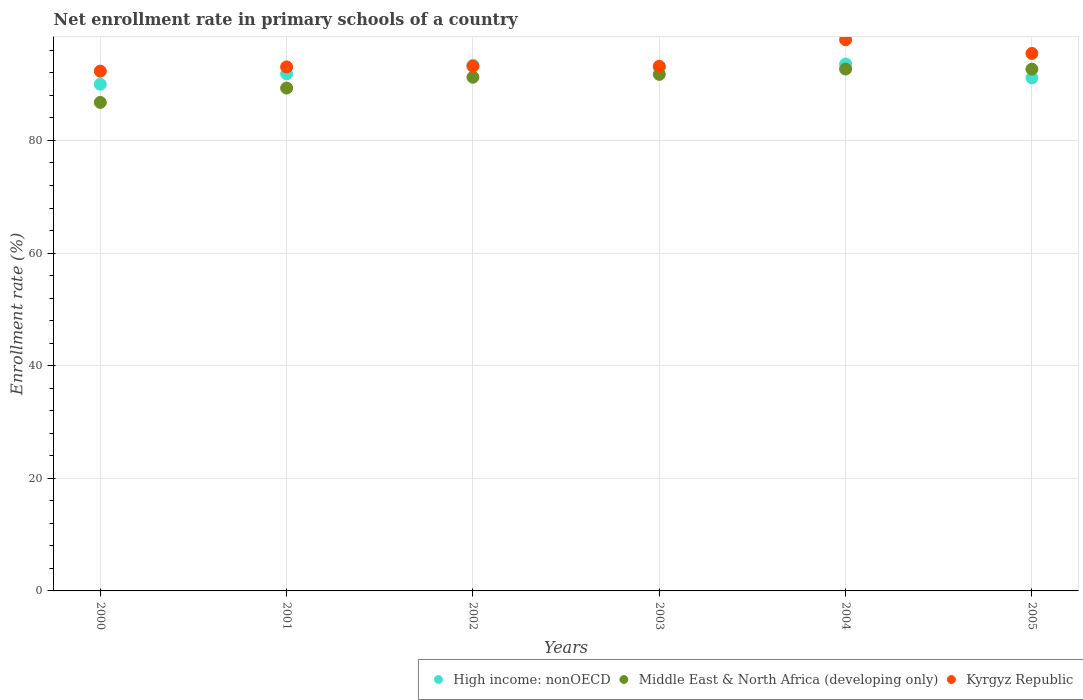How many different coloured dotlines are there?
Offer a terse response. 3. Is the number of dotlines equal to the number of legend labels?
Your response must be concise. Yes. What is the enrollment rate in primary schools in High income: nonOECD in 2004?
Make the answer very short. 93.57. Across all years, what is the maximum enrollment rate in primary schools in High income: nonOECD?
Give a very brief answer. 93.57. Across all years, what is the minimum enrollment rate in primary schools in High income: nonOECD?
Your response must be concise. 89.98. In which year was the enrollment rate in primary schools in High income: nonOECD maximum?
Ensure brevity in your answer.  2004. What is the total enrollment rate in primary schools in High income: nonOECD in the graph?
Offer a very short reply. 552.82. What is the difference between the enrollment rate in primary schools in Middle East & North Africa (developing only) in 2000 and that in 2003?
Offer a terse response. -4.97. What is the difference between the enrollment rate in primary schools in Kyrgyz Republic in 2003 and the enrollment rate in primary schools in Middle East & North Africa (developing only) in 2005?
Provide a short and direct response. 0.51. What is the average enrollment rate in primary schools in High income: nonOECD per year?
Offer a terse response. 92.14. In the year 2001, what is the difference between the enrollment rate in primary schools in Middle East & North Africa (developing only) and enrollment rate in primary schools in High income: nonOECD?
Your answer should be compact. -2.53. In how many years, is the enrollment rate in primary schools in Middle East & North Africa (developing only) greater than 72 %?
Keep it short and to the point. 6. What is the ratio of the enrollment rate in primary schools in High income: nonOECD in 2003 to that in 2004?
Your response must be concise. 0.99. Is the enrollment rate in primary schools in High income: nonOECD in 2003 less than that in 2004?
Offer a terse response. Yes. What is the difference between the highest and the second highest enrollment rate in primary schools in Middle East & North Africa (developing only)?
Your answer should be very brief. 0.02. What is the difference between the highest and the lowest enrollment rate in primary schools in Kyrgyz Republic?
Provide a succinct answer. 5.58. In how many years, is the enrollment rate in primary schools in Kyrgyz Republic greater than the average enrollment rate in primary schools in Kyrgyz Republic taken over all years?
Provide a succinct answer. 2. Is the sum of the enrollment rate in primary schools in Middle East & North Africa (developing only) in 2001 and 2003 greater than the maximum enrollment rate in primary schools in High income: nonOECD across all years?
Your answer should be very brief. Yes. Is the enrollment rate in primary schools in High income: nonOECD strictly greater than the enrollment rate in primary schools in Kyrgyz Republic over the years?
Your answer should be compact. No. Are the values on the major ticks of Y-axis written in scientific E-notation?
Offer a terse response. No. Does the graph contain any zero values?
Your answer should be compact. No. Does the graph contain grids?
Your answer should be very brief. Yes. Where does the legend appear in the graph?
Your answer should be compact. Bottom right. What is the title of the graph?
Give a very brief answer. Net enrollment rate in primary schools of a country. Does "South Sudan" appear as one of the legend labels in the graph?
Offer a terse response. No. What is the label or title of the Y-axis?
Ensure brevity in your answer.  Enrollment rate (%). What is the Enrollment rate (%) in High income: nonOECD in 2000?
Provide a short and direct response. 89.98. What is the Enrollment rate (%) of Middle East & North Africa (developing only) in 2000?
Give a very brief answer. 86.76. What is the Enrollment rate (%) of Kyrgyz Republic in 2000?
Keep it short and to the point. 92.31. What is the Enrollment rate (%) in High income: nonOECD in 2001?
Keep it short and to the point. 91.83. What is the Enrollment rate (%) of Middle East & North Africa (developing only) in 2001?
Your response must be concise. 89.3. What is the Enrollment rate (%) of Kyrgyz Republic in 2001?
Ensure brevity in your answer.  93.06. What is the Enrollment rate (%) of High income: nonOECD in 2002?
Provide a succinct answer. 93.35. What is the Enrollment rate (%) of Middle East & North Africa (developing only) in 2002?
Give a very brief answer. 91.23. What is the Enrollment rate (%) in Kyrgyz Republic in 2002?
Offer a terse response. 93.19. What is the Enrollment rate (%) in High income: nonOECD in 2003?
Provide a succinct answer. 92.97. What is the Enrollment rate (%) of Middle East & North Africa (developing only) in 2003?
Give a very brief answer. 91.73. What is the Enrollment rate (%) of Kyrgyz Republic in 2003?
Provide a short and direct response. 93.17. What is the Enrollment rate (%) of High income: nonOECD in 2004?
Keep it short and to the point. 93.57. What is the Enrollment rate (%) of Middle East & North Africa (developing only) in 2004?
Keep it short and to the point. 92.68. What is the Enrollment rate (%) of Kyrgyz Republic in 2004?
Make the answer very short. 97.89. What is the Enrollment rate (%) of High income: nonOECD in 2005?
Offer a very short reply. 91.12. What is the Enrollment rate (%) in Middle East & North Africa (developing only) in 2005?
Make the answer very short. 92.66. What is the Enrollment rate (%) of Kyrgyz Republic in 2005?
Offer a very short reply. 95.45. Across all years, what is the maximum Enrollment rate (%) of High income: nonOECD?
Give a very brief answer. 93.57. Across all years, what is the maximum Enrollment rate (%) of Middle East & North Africa (developing only)?
Offer a terse response. 92.68. Across all years, what is the maximum Enrollment rate (%) in Kyrgyz Republic?
Provide a succinct answer. 97.89. Across all years, what is the minimum Enrollment rate (%) of High income: nonOECD?
Your response must be concise. 89.98. Across all years, what is the minimum Enrollment rate (%) in Middle East & North Africa (developing only)?
Provide a succinct answer. 86.76. Across all years, what is the minimum Enrollment rate (%) of Kyrgyz Republic?
Offer a very short reply. 92.31. What is the total Enrollment rate (%) in High income: nonOECD in the graph?
Provide a short and direct response. 552.82. What is the total Enrollment rate (%) in Middle East & North Africa (developing only) in the graph?
Your answer should be very brief. 544.36. What is the total Enrollment rate (%) in Kyrgyz Republic in the graph?
Make the answer very short. 565.07. What is the difference between the Enrollment rate (%) of High income: nonOECD in 2000 and that in 2001?
Offer a terse response. -1.85. What is the difference between the Enrollment rate (%) of Middle East & North Africa (developing only) in 2000 and that in 2001?
Provide a short and direct response. -2.54. What is the difference between the Enrollment rate (%) in Kyrgyz Republic in 2000 and that in 2001?
Ensure brevity in your answer.  -0.75. What is the difference between the Enrollment rate (%) in High income: nonOECD in 2000 and that in 2002?
Your answer should be very brief. -3.37. What is the difference between the Enrollment rate (%) of Middle East & North Africa (developing only) in 2000 and that in 2002?
Offer a very short reply. -4.47. What is the difference between the Enrollment rate (%) in Kyrgyz Republic in 2000 and that in 2002?
Your answer should be very brief. -0.88. What is the difference between the Enrollment rate (%) of High income: nonOECD in 2000 and that in 2003?
Provide a succinct answer. -2.99. What is the difference between the Enrollment rate (%) in Middle East & North Africa (developing only) in 2000 and that in 2003?
Ensure brevity in your answer.  -4.97. What is the difference between the Enrollment rate (%) of Kyrgyz Republic in 2000 and that in 2003?
Your answer should be compact. -0.86. What is the difference between the Enrollment rate (%) of High income: nonOECD in 2000 and that in 2004?
Ensure brevity in your answer.  -3.6. What is the difference between the Enrollment rate (%) of Middle East & North Africa (developing only) in 2000 and that in 2004?
Your answer should be very brief. -5.92. What is the difference between the Enrollment rate (%) of Kyrgyz Republic in 2000 and that in 2004?
Give a very brief answer. -5.58. What is the difference between the Enrollment rate (%) in High income: nonOECD in 2000 and that in 2005?
Provide a short and direct response. -1.15. What is the difference between the Enrollment rate (%) of Middle East & North Africa (developing only) in 2000 and that in 2005?
Offer a terse response. -5.91. What is the difference between the Enrollment rate (%) of Kyrgyz Republic in 2000 and that in 2005?
Give a very brief answer. -3.14. What is the difference between the Enrollment rate (%) in High income: nonOECD in 2001 and that in 2002?
Offer a very short reply. -1.52. What is the difference between the Enrollment rate (%) in Middle East & North Africa (developing only) in 2001 and that in 2002?
Offer a very short reply. -1.93. What is the difference between the Enrollment rate (%) of Kyrgyz Republic in 2001 and that in 2002?
Make the answer very short. -0.13. What is the difference between the Enrollment rate (%) in High income: nonOECD in 2001 and that in 2003?
Keep it short and to the point. -1.14. What is the difference between the Enrollment rate (%) in Middle East & North Africa (developing only) in 2001 and that in 2003?
Your response must be concise. -2.43. What is the difference between the Enrollment rate (%) of Kyrgyz Republic in 2001 and that in 2003?
Keep it short and to the point. -0.11. What is the difference between the Enrollment rate (%) in High income: nonOECD in 2001 and that in 2004?
Your answer should be compact. -1.75. What is the difference between the Enrollment rate (%) of Middle East & North Africa (developing only) in 2001 and that in 2004?
Offer a terse response. -3.38. What is the difference between the Enrollment rate (%) in Kyrgyz Republic in 2001 and that in 2004?
Make the answer very short. -4.83. What is the difference between the Enrollment rate (%) of High income: nonOECD in 2001 and that in 2005?
Ensure brevity in your answer.  0.71. What is the difference between the Enrollment rate (%) in Middle East & North Africa (developing only) in 2001 and that in 2005?
Your response must be concise. -3.36. What is the difference between the Enrollment rate (%) in Kyrgyz Republic in 2001 and that in 2005?
Your answer should be very brief. -2.39. What is the difference between the Enrollment rate (%) of High income: nonOECD in 2002 and that in 2003?
Offer a very short reply. 0.38. What is the difference between the Enrollment rate (%) in Middle East & North Africa (developing only) in 2002 and that in 2003?
Ensure brevity in your answer.  -0.5. What is the difference between the Enrollment rate (%) of Kyrgyz Republic in 2002 and that in 2003?
Offer a terse response. 0.01. What is the difference between the Enrollment rate (%) of High income: nonOECD in 2002 and that in 2004?
Your answer should be very brief. -0.22. What is the difference between the Enrollment rate (%) in Middle East & North Africa (developing only) in 2002 and that in 2004?
Provide a short and direct response. -1.45. What is the difference between the Enrollment rate (%) in Kyrgyz Republic in 2002 and that in 2004?
Your response must be concise. -4.7. What is the difference between the Enrollment rate (%) of High income: nonOECD in 2002 and that in 2005?
Offer a very short reply. 2.23. What is the difference between the Enrollment rate (%) of Middle East & North Africa (developing only) in 2002 and that in 2005?
Your answer should be very brief. -1.43. What is the difference between the Enrollment rate (%) of Kyrgyz Republic in 2002 and that in 2005?
Make the answer very short. -2.27. What is the difference between the Enrollment rate (%) of High income: nonOECD in 2003 and that in 2004?
Provide a succinct answer. -0.61. What is the difference between the Enrollment rate (%) in Middle East & North Africa (developing only) in 2003 and that in 2004?
Offer a terse response. -0.95. What is the difference between the Enrollment rate (%) in Kyrgyz Republic in 2003 and that in 2004?
Make the answer very short. -4.72. What is the difference between the Enrollment rate (%) in High income: nonOECD in 2003 and that in 2005?
Your answer should be very brief. 1.84. What is the difference between the Enrollment rate (%) of Middle East & North Africa (developing only) in 2003 and that in 2005?
Provide a succinct answer. -0.94. What is the difference between the Enrollment rate (%) of Kyrgyz Republic in 2003 and that in 2005?
Keep it short and to the point. -2.28. What is the difference between the Enrollment rate (%) of High income: nonOECD in 2004 and that in 2005?
Provide a short and direct response. 2.45. What is the difference between the Enrollment rate (%) of Middle East & North Africa (developing only) in 2004 and that in 2005?
Your response must be concise. 0.02. What is the difference between the Enrollment rate (%) of Kyrgyz Republic in 2004 and that in 2005?
Offer a very short reply. 2.44. What is the difference between the Enrollment rate (%) of High income: nonOECD in 2000 and the Enrollment rate (%) of Middle East & North Africa (developing only) in 2001?
Make the answer very short. 0.67. What is the difference between the Enrollment rate (%) in High income: nonOECD in 2000 and the Enrollment rate (%) in Kyrgyz Republic in 2001?
Give a very brief answer. -3.08. What is the difference between the Enrollment rate (%) of Middle East & North Africa (developing only) in 2000 and the Enrollment rate (%) of Kyrgyz Republic in 2001?
Provide a succinct answer. -6.3. What is the difference between the Enrollment rate (%) in High income: nonOECD in 2000 and the Enrollment rate (%) in Middle East & North Africa (developing only) in 2002?
Provide a short and direct response. -1.25. What is the difference between the Enrollment rate (%) in High income: nonOECD in 2000 and the Enrollment rate (%) in Kyrgyz Republic in 2002?
Offer a very short reply. -3.21. What is the difference between the Enrollment rate (%) of Middle East & North Africa (developing only) in 2000 and the Enrollment rate (%) of Kyrgyz Republic in 2002?
Provide a short and direct response. -6.43. What is the difference between the Enrollment rate (%) in High income: nonOECD in 2000 and the Enrollment rate (%) in Middle East & North Africa (developing only) in 2003?
Offer a very short reply. -1.75. What is the difference between the Enrollment rate (%) of High income: nonOECD in 2000 and the Enrollment rate (%) of Kyrgyz Republic in 2003?
Keep it short and to the point. -3.2. What is the difference between the Enrollment rate (%) in Middle East & North Africa (developing only) in 2000 and the Enrollment rate (%) in Kyrgyz Republic in 2003?
Your answer should be compact. -6.41. What is the difference between the Enrollment rate (%) in High income: nonOECD in 2000 and the Enrollment rate (%) in Middle East & North Africa (developing only) in 2004?
Ensure brevity in your answer.  -2.71. What is the difference between the Enrollment rate (%) of High income: nonOECD in 2000 and the Enrollment rate (%) of Kyrgyz Republic in 2004?
Give a very brief answer. -7.91. What is the difference between the Enrollment rate (%) in Middle East & North Africa (developing only) in 2000 and the Enrollment rate (%) in Kyrgyz Republic in 2004?
Your answer should be compact. -11.13. What is the difference between the Enrollment rate (%) of High income: nonOECD in 2000 and the Enrollment rate (%) of Middle East & North Africa (developing only) in 2005?
Make the answer very short. -2.69. What is the difference between the Enrollment rate (%) in High income: nonOECD in 2000 and the Enrollment rate (%) in Kyrgyz Republic in 2005?
Provide a succinct answer. -5.48. What is the difference between the Enrollment rate (%) in Middle East & North Africa (developing only) in 2000 and the Enrollment rate (%) in Kyrgyz Republic in 2005?
Your answer should be very brief. -8.69. What is the difference between the Enrollment rate (%) in High income: nonOECD in 2001 and the Enrollment rate (%) in Middle East & North Africa (developing only) in 2002?
Keep it short and to the point. 0.6. What is the difference between the Enrollment rate (%) of High income: nonOECD in 2001 and the Enrollment rate (%) of Kyrgyz Republic in 2002?
Provide a short and direct response. -1.36. What is the difference between the Enrollment rate (%) of Middle East & North Africa (developing only) in 2001 and the Enrollment rate (%) of Kyrgyz Republic in 2002?
Offer a terse response. -3.88. What is the difference between the Enrollment rate (%) of High income: nonOECD in 2001 and the Enrollment rate (%) of Middle East & North Africa (developing only) in 2003?
Your answer should be very brief. 0.1. What is the difference between the Enrollment rate (%) of High income: nonOECD in 2001 and the Enrollment rate (%) of Kyrgyz Republic in 2003?
Give a very brief answer. -1.34. What is the difference between the Enrollment rate (%) of Middle East & North Africa (developing only) in 2001 and the Enrollment rate (%) of Kyrgyz Republic in 2003?
Your response must be concise. -3.87. What is the difference between the Enrollment rate (%) of High income: nonOECD in 2001 and the Enrollment rate (%) of Middle East & North Africa (developing only) in 2004?
Your response must be concise. -0.85. What is the difference between the Enrollment rate (%) of High income: nonOECD in 2001 and the Enrollment rate (%) of Kyrgyz Republic in 2004?
Offer a terse response. -6.06. What is the difference between the Enrollment rate (%) of Middle East & North Africa (developing only) in 2001 and the Enrollment rate (%) of Kyrgyz Republic in 2004?
Offer a very short reply. -8.59. What is the difference between the Enrollment rate (%) of High income: nonOECD in 2001 and the Enrollment rate (%) of Middle East & North Africa (developing only) in 2005?
Keep it short and to the point. -0.83. What is the difference between the Enrollment rate (%) of High income: nonOECD in 2001 and the Enrollment rate (%) of Kyrgyz Republic in 2005?
Offer a terse response. -3.62. What is the difference between the Enrollment rate (%) of Middle East & North Africa (developing only) in 2001 and the Enrollment rate (%) of Kyrgyz Republic in 2005?
Offer a very short reply. -6.15. What is the difference between the Enrollment rate (%) of High income: nonOECD in 2002 and the Enrollment rate (%) of Middle East & North Africa (developing only) in 2003?
Your answer should be very brief. 1.62. What is the difference between the Enrollment rate (%) in High income: nonOECD in 2002 and the Enrollment rate (%) in Kyrgyz Republic in 2003?
Ensure brevity in your answer.  0.18. What is the difference between the Enrollment rate (%) in Middle East & North Africa (developing only) in 2002 and the Enrollment rate (%) in Kyrgyz Republic in 2003?
Provide a short and direct response. -1.94. What is the difference between the Enrollment rate (%) of High income: nonOECD in 2002 and the Enrollment rate (%) of Middle East & North Africa (developing only) in 2004?
Offer a terse response. 0.67. What is the difference between the Enrollment rate (%) of High income: nonOECD in 2002 and the Enrollment rate (%) of Kyrgyz Republic in 2004?
Your answer should be compact. -4.54. What is the difference between the Enrollment rate (%) in Middle East & North Africa (developing only) in 2002 and the Enrollment rate (%) in Kyrgyz Republic in 2004?
Give a very brief answer. -6.66. What is the difference between the Enrollment rate (%) of High income: nonOECD in 2002 and the Enrollment rate (%) of Middle East & North Africa (developing only) in 2005?
Your response must be concise. 0.69. What is the difference between the Enrollment rate (%) of High income: nonOECD in 2002 and the Enrollment rate (%) of Kyrgyz Republic in 2005?
Your response must be concise. -2.1. What is the difference between the Enrollment rate (%) in Middle East & North Africa (developing only) in 2002 and the Enrollment rate (%) in Kyrgyz Republic in 2005?
Provide a succinct answer. -4.22. What is the difference between the Enrollment rate (%) in High income: nonOECD in 2003 and the Enrollment rate (%) in Middle East & North Africa (developing only) in 2004?
Your answer should be very brief. 0.29. What is the difference between the Enrollment rate (%) in High income: nonOECD in 2003 and the Enrollment rate (%) in Kyrgyz Republic in 2004?
Provide a short and direct response. -4.92. What is the difference between the Enrollment rate (%) of Middle East & North Africa (developing only) in 2003 and the Enrollment rate (%) of Kyrgyz Republic in 2004?
Offer a very short reply. -6.16. What is the difference between the Enrollment rate (%) in High income: nonOECD in 2003 and the Enrollment rate (%) in Middle East & North Africa (developing only) in 2005?
Your answer should be very brief. 0.3. What is the difference between the Enrollment rate (%) in High income: nonOECD in 2003 and the Enrollment rate (%) in Kyrgyz Republic in 2005?
Provide a short and direct response. -2.48. What is the difference between the Enrollment rate (%) of Middle East & North Africa (developing only) in 2003 and the Enrollment rate (%) of Kyrgyz Republic in 2005?
Keep it short and to the point. -3.72. What is the difference between the Enrollment rate (%) of High income: nonOECD in 2004 and the Enrollment rate (%) of Middle East & North Africa (developing only) in 2005?
Your answer should be compact. 0.91. What is the difference between the Enrollment rate (%) in High income: nonOECD in 2004 and the Enrollment rate (%) in Kyrgyz Republic in 2005?
Give a very brief answer. -1.88. What is the difference between the Enrollment rate (%) in Middle East & North Africa (developing only) in 2004 and the Enrollment rate (%) in Kyrgyz Republic in 2005?
Offer a very short reply. -2.77. What is the average Enrollment rate (%) of High income: nonOECD per year?
Your response must be concise. 92.14. What is the average Enrollment rate (%) in Middle East & North Africa (developing only) per year?
Ensure brevity in your answer.  90.73. What is the average Enrollment rate (%) of Kyrgyz Republic per year?
Ensure brevity in your answer.  94.18. In the year 2000, what is the difference between the Enrollment rate (%) in High income: nonOECD and Enrollment rate (%) in Middle East & North Africa (developing only)?
Your response must be concise. 3.22. In the year 2000, what is the difference between the Enrollment rate (%) of High income: nonOECD and Enrollment rate (%) of Kyrgyz Republic?
Provide a succinct answer. -2.33. In the year 2000, what is the difference between the Enrollment rate (%) of Middle East & North Africa (developing only) and Enrollment rate (%) of Kyrgyz Republic?
Keep it short and to the point. -5.55. In the year 2001, what is the difference between the Enrollment rate (%) of High income: nonOECD and Enrollment rate (%) of Middle East & North Africa (developing only)?
Provide a short and direct response. 2.53. In the year 2001, what is the difference between the Enrollment rate (%) in High income: nonOECD and Enrollment rate (%) in Kyrgyz Republic?
Give a very brief answer. -1.23. In the year 2001, what is the difference between the Enrollment rate (%) of Middle East & North Africa (developing only) and Enrollment rate (%) of Kyrgyz Republic?
Your answer should be compact. -3.76. In the year 2002, what is the difference between the Enrollment rate (%) of High income: nonOECD and Enrollment rate (%) of Middle East & North Africa (developing only)?
Provide a short and direct response. 2.12. In the year 2002, what is the difference between the Enrollment rate (%) of High income: nonOECD and Enrollment rate (%) of Kyrgyz Republic?
Provide a succinct answer. 0.16. In the year 2002, what is the difference between the Enrollment rate (%) of Middle East & North Africa (developing only) and Enrollment rate (%) of Kyrgyz Republic?
Offer a very short reply. -1.96. In the year 2003, what is the difference between the Enrollment rate (%) of High income: nonOECD and Enrollment rate (%) of Middle East & North Africa (developing only)?
Keep it short and to the point. 1.24. In the year 2003, what is the difference between the Enrollment rate (%) in High income: nonOECD and Enrollment rate (%) in Kyrgyz Republic?
Keep it short and to the point. -0.2. In the year 2003, what is the difference between the Enrollment rate (%) in Middle East & North Africa (developing only) and Enrollment rate (%) in Kyrgyz Republic?
Make the answer very short. -1.44. In the year 2004, what is the difference between the Enrollment rate (%) of High income: nonOECD and Enrollment rate (%) of Middle East & North Africa (developing only)?
Your answer should be compact. 0.89. In the year 2004, what is the difference between the Enrollment rate (%) of High income: nonOECD and Enrollment rate (%) of Kyrgyz Republic?
Keep it short and to the point. -4.32. In the year 2004, what is the difference between the Enrollment rate (%) of Middle East & North Africa (developing only) and Enrollment rate (%) of Kyrgyz Republic?
Your answer should be very brief. -5.21. In the year 2005, what is the difference between the Enrollment rate (%) in High income: nonOECD and Enrollment rate (%) in Middle East & North Africa (developing only)?
Keep it short and to the point. -1.54. In the year 2005, what is the difference between the Enrollment rate (%) of High income: nonOECD and Enrollment rate (%) of Kyrgyz Republic?
Provide a succinct answer. -4.33. In the year 2005, what is the difference between the Enrollment rate (%) in Middle East & North Africa (developing only) and Enrollment rate (%) in Kyrgyz Republic?
Provide a succinct answer. -2.79. What is the ratio of the Enrollment rate (%) in High income: nonOECD in 2000 to that in 2001?
Your answer should be compact. 0.98. What is the ratio of the Enrollment rate (%) in Middle East & North Africa (developing only) in 2000 to that in 2001?
Your response must be concise. 0.97. What is the ratio of the Enrollment rate (%) of High income: nonOECD in 2000 to that in 2002?
Your answer should be compact. 0.96. What is the ratio of the Enrollment rate (%) in Middle East & North Africa (developing only) in 2000 to that in 2002?
Your answer should be very brief. 0.95. What is the ratio of the Enrollment rate (%) in Kyrgyz Republic in 2000 to that in 2002?
Your answer should be compact. 0.99. What is the ratio of the Enrollment rate (%) of High income: nonOECD in 2000 to that in 2003?
Offer a terse response. 0.97. What is the ratio of the Enrollment rate (%) of Middle East & North Africa (developing only) in 2000 to that in 2003?
Provide a succinct answer. 0.95. What is the ratio of the Enrollment rate (%) of High income: nonOECD in 2000 to that in 2004?
Provide a succinct answer. 0.96. What is the ratio of the Enrollment rate (%) of Middle East & North Africa (developing only) in 2000 to that in 2004?
Offer a terse response. 0.94. What is the ratio of the Enrollment rate (%) of Kyrgyz Republic in 2000 to that in 2004?
Give a very brief answer. 0.94. What is the ratio of the Enrollment rate (%) of High income: nonOECD in 2000 to that in 2005?
Your answer should be compact. 0.99. What is the ratio of the Enrollment rate (%) in Middle East & North Africa (developing only) in 2000 to that in 2005?
Offer a very short reply. 0.94. What is the ratio of the Enrollment rate (%) of Kyrgyz Republic in 2000 to that in 2005?
Provide a succinct answer. 0.97. What is the ratio of the Enrollment rate (%) in High income: nonOECD in 2001 to that in 2002?
Keep it short and to the point. 0.98. What is the ratio of the Enrollment rate (%) in Middle East & North Africa (developing only) in 2001 to that in 2002?
Your response must be concise. 0.98. What is the ratio of the Enrollment rate (%) of Kyrgyz Republic in 2001 to that in 2002?
Keep it short and to the point. 1. What is the ratio of the Enrollment rate (%) of High income: nonOECD in 2001 to that in 2003?
Keep it short and to the point. 0.99. What is the ratio of the Enrollment rate (%) in Middle East & North Africa (developing only) in 2001 to that in 2003?
Keep it short and to the point. 0.97. What is the ratio of the Enrollment rate (%) of Kyrgyz Republic in 2001 to that in 2003?
Offer a terse response. 1. What is the ratio of the Enrollment rate (%) of High income: nonOECD in 2001 to that in 2004?
Provide a succinct answer. 0.98. What is the ratio of the Enrollment rate (%) in Middle East & North Africa (developing only) in 2001 to that in 2004?
Provide a short and direct response. 0.96. What is the ratio of the Enrollment rate (%) of Kyrgyz Republic in 2001 to that in 2004?
Ensure brevity in your answer.  0.95. What is the ratio of the Enrollment rate (%) in Middle East & North Africa (developing only) in 2001 to that in 2005?
Offer a very short reply. 0.96. What is the ratio of the Enrollment rate (%) in Kyrgyz Republic in 2001 to that in 2005?
Keep it short and to the point. 0.97. What is the ratio of the Enrollment rate (%) in High income: nonOECD in 2002 to that in 2003?
Offer a terse response. 1. What is the ratio of the Enrollment rate (%) of Middle East & North Africa (developing only) in 2002 to that in 2003?
Your answer should be compact. 0.99. What is the ratio of the Enrollment rate (%) of Kyrgyz Republic in 2002 to that in 2003?
Provide a succinct answer. 1. What is the ratio of the Enrollment rate (%) of High income: nonOECD in 2002 to that in 2004?
Offer a very short reply. 1. What is the ratio of the Enrollment rate (%) in Middle East & North Africa (developing only) in 2002 to that in 2004?
Provide a succinct answer. 0.98. What is the ratio of the Enrollment rate (%) of Kyrgyz Republic in 2002 to that in 2004?
Your response must be concise. 0.95. What is the ratio of the Enrollment rate (%) in High income: nonOECD in 2002 to that in 2005?
Offer a terse response. 1.02. What is the ratio of the Enrollment rate (%) in Middle East & North Africa (developing only) in 2002 to that in 2005?
Provide a succinct answer. 0.98. What is the ratio of the Enrollment rate (%) in Kyrgyz Republic in 2002 to that in 2005?
Provide a short and direct response. 0.98. What is the ratio of the Enrollment rate (%) of High income: nonOECD in 2003 to that in 2004?
Your answer should be very brief. 0.99. What is the ratio of the Enrollment rate (%) of Kyrgyz Republic in 2003 to that in 2004?
Provide a short and direct response. 0.95. What is the ratio of the Enrollment rate (%) in High income: nonOECD in 2003 to that in 2005?
Your response must be concise. 1.02. What is the ratio of the Enrollment rate (%) in Kyrgyz Republic in 2003 to that in 2005?
Offer a terse response. 0.98. What is the ratio of the Enrollment rate (%) of High income: nonOECD in 2004 to that in 2005?
Make the answer very short. 1.03. What is the ratio of the Enrollment rate (%) of Kyrgyz Republic in 2004 to that in 2005?
Keep it short and to the point. 1.03. What is the difference between the highest and the second highest Enrollment rate (%) of High income: nonOECD?
Your answer should be compact. 0.22. What is the difference between the highest and the second highest Enrollment rate (%) in Middle East & North Africa (developing only)?
Your response must be concise. 0.02. What is the difference between the highest and the second highest Enrollment rate (%) in Kyrgyz Republic?
Your answer should be very brief. 2.44. What is the difference between the highest and the lowest Enrollment rate (%) of High income: nonOECD?
Ensure brevity in your answer.  3.6. What is the difference between the highest and the lowest Enrollment rate (%) of Middle East & North Africa (developing only)?
Ensure brevity in your answer.  5.92. What is the difference between the highest and the lowest Enrollment rate (%) of Kyrgyz Republic?
Keep it short and to the point. 5.58. 